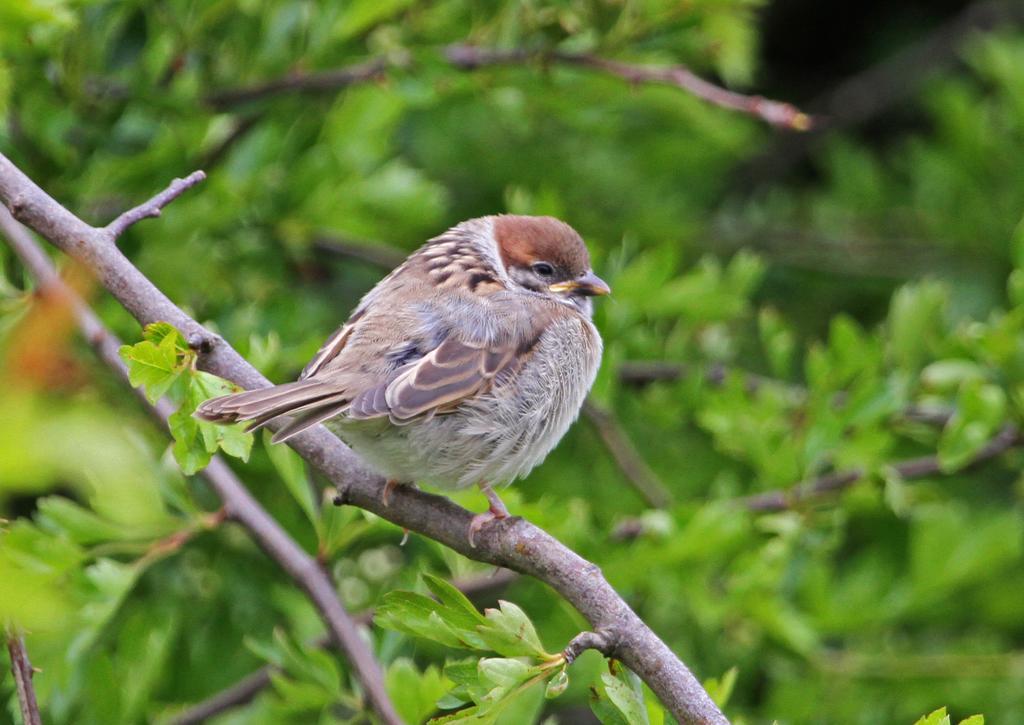How would you summarize this image in a sentence or two? In this picture we can see a bird is standing on a branch of a tree, in the background we can see leaves, there is a blurry background. 